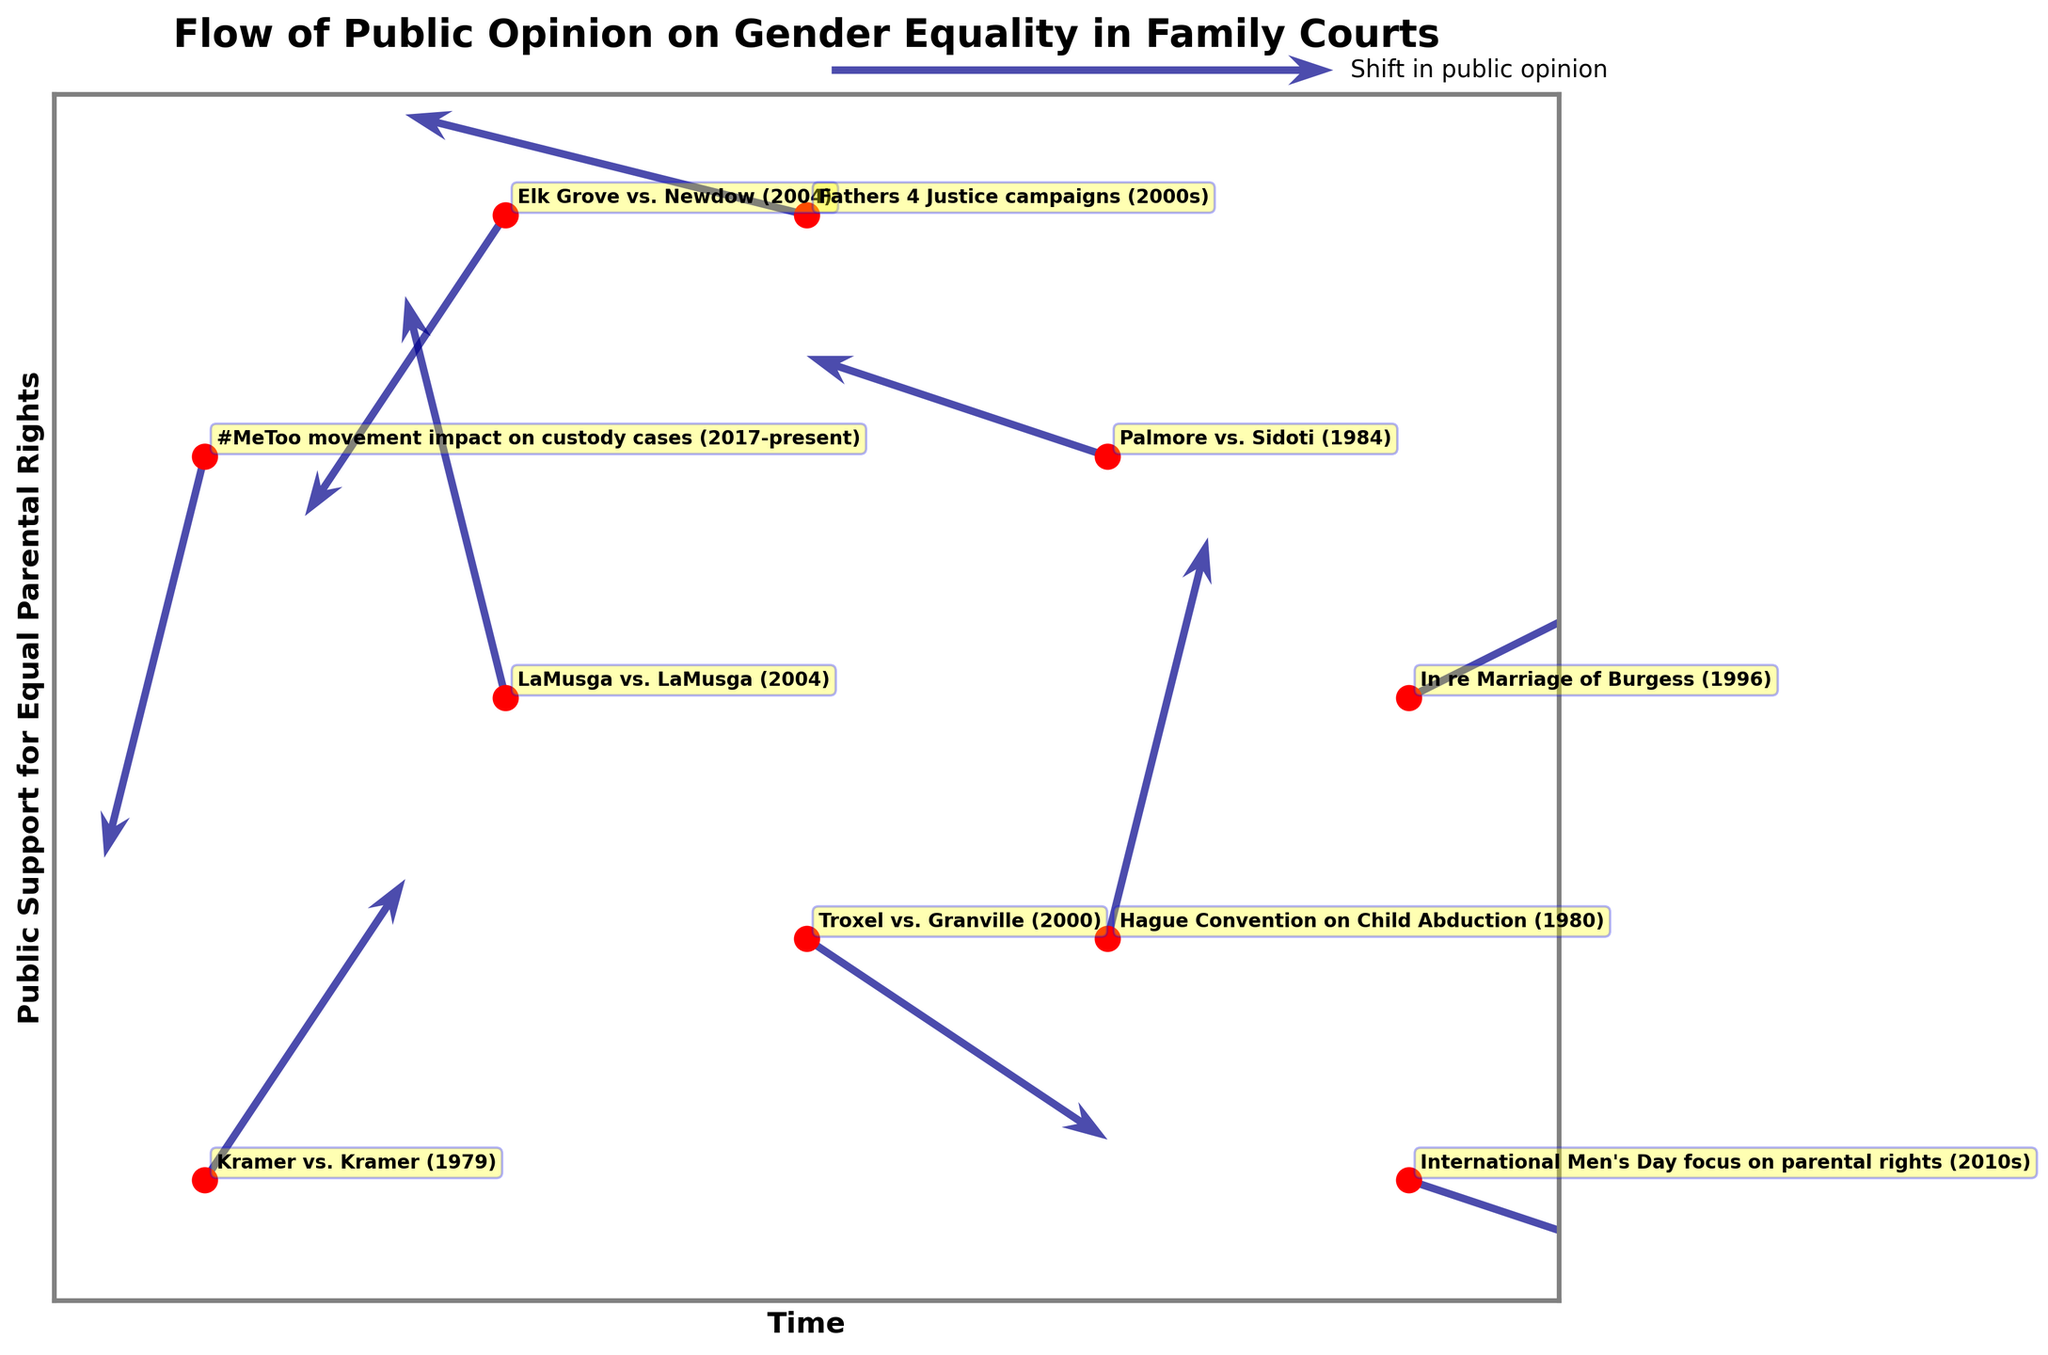How many high-profile cases are plotted on the figure? By counting the number of annotated points on the plot, each representing a high-profile case, we can determine the total.
Answer: 10 Which case corresponds to the starting X,Y coordinates (0,0)? Locate the annotated point at the origin (0,0) and read the corresponding case label.
Answer: "Kramer vs. Kramer (1979)" What is the general trend in public opinion for the "Elk Grove vs. Newdow (2004)" case? Look at the arrow starting from the point annotated as "Elk Grove vs. Newdow (2004)". The direction of the arrow indicates the trend. It moves left and downwards, indicating a negative shift.
Answer: Negative shift in public support Which two cases have arrows pointing upwards, indicating an increase in public support? Find arrows pointing upwards (positive Y direction) and read the labels of their starting points.
Answer: "Kramer vs. Kramer (1979)" and "LaMusga vs. LaMusga (2004)" What is the maximum shift in the X direction, and which case does it correspond to? Measure the length of all arrows in the X direction and identify the maximum value. The case it corresponds to is "In re Marriage of Burgess (1996)".
Answer: 0.4, "In re Marriage of Burgess (1996)" Between which cases is the shift in public opinion most balanced in the X and Y directions? Look for arrows where ∆X and ∆Y are of similar magnitudes. The case "Hague Convention on Child Abduction (1980)" shows balanced movement with 0.1 in X and 0.4 in Y directions.
Answer: "Hague Convention on Child Abduction (1980)" Which case shows the largest decrease in both X and Y directions, indicating a decline in public support? Identify the case with the most negative components in both ∆X and ∆Y directions. The case "#MeToo movement impact on custody cases (2017-present)" has a decline with ∆X = -0.1 and ∆Y = -0.4.
Answer: "#MeToo movement impact on custody cases (2017-present)" How many cases show no horizontal movement (∆X=0)? Count the cases where the arrow has no component in the X direction. In this plot, there are no such cases.
Answer: 0 What is the trend in public opinion for the "International Men's Day focus on parental rights (2010s)" case? Observe the direction of the arrow from the annotated "International Men's Day focus on parental rights (2010s)" point. It shows a rightward shift in X and a slight downward shift in Y, indicating increasing and slightly decreasing support, respectively.
Answer: Complex shift: Increasing in X, decreasing slightly in Y Which case has the smallest magnitude shift, indicating a relatively unchanged public opinion? Calculate the magnitudes using √(ΔX^2 + ΔY^2) for each case. "Palmore vs. Sidoti (1984)" has one of the smaller magnitudes with ΔX = -0.3 and ΔY = 0.1, resulting in a magnitude of approximately 0.316.
Answer: "Palmore vs. Sidoti (1984)" 